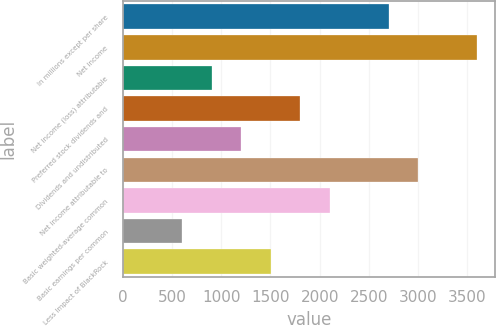Convert chart. <chart><loc_0><loc_0><loc_500><loc_500><bar_chart><fcel>In millions except per share<fcel>Net income<fcel>Net income (loss) attributable<fcel>Preferred stock dividends and<fcel>Dividends and undistributed<fcel>Net income attributable to<fcel>Basic weighted-average common<fcel>Basic earnings per common<fcel>Less Impact of BlackRock<nl><fcel>2701.2<fcel>3600.6<fcel>902.4<fcel>1801.8<fcel>1202.2<fcel>3001<fcel>2101.6<fcel>602.6<fcel>1502<nl></chart> 